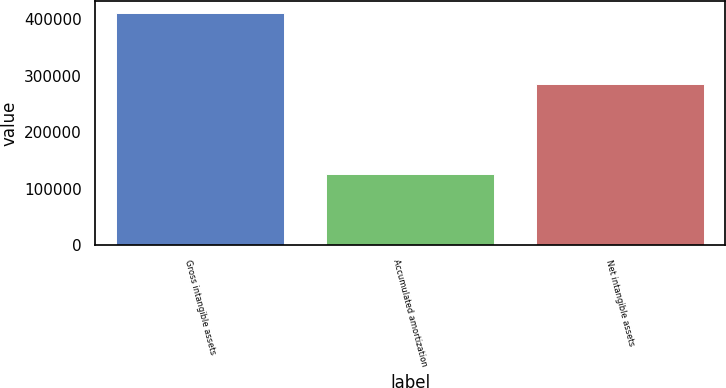Convert chart. <chart><loc_0><loc_0><loc_500><loc_500><bar_chart><fcel>Gross intangible assets<fcel>Accumulated amortization<fcel>Net intangible assets<nl><fcel>411650<fcel>125608<fcel>286042<nl></chart> 